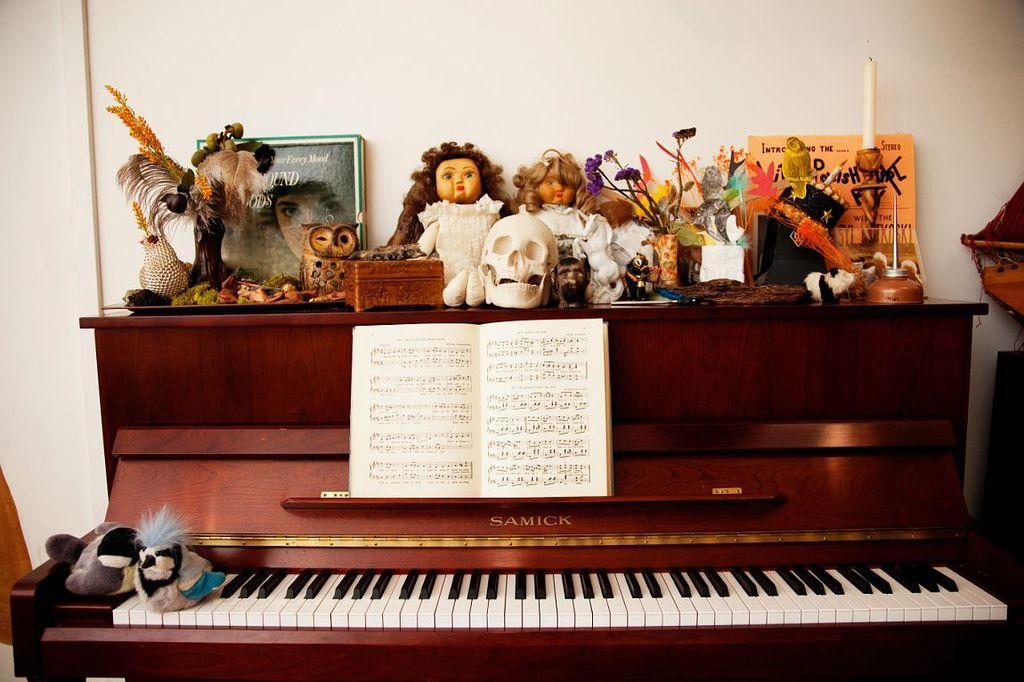Could you give a brief overview of what you see in this image? The image looks like it is clicked inside a room. There is a piano in brown color, on which there is a music notes and dolls, skull, Photo frames, flower vase are kept. In the background there is a wall in white color. 